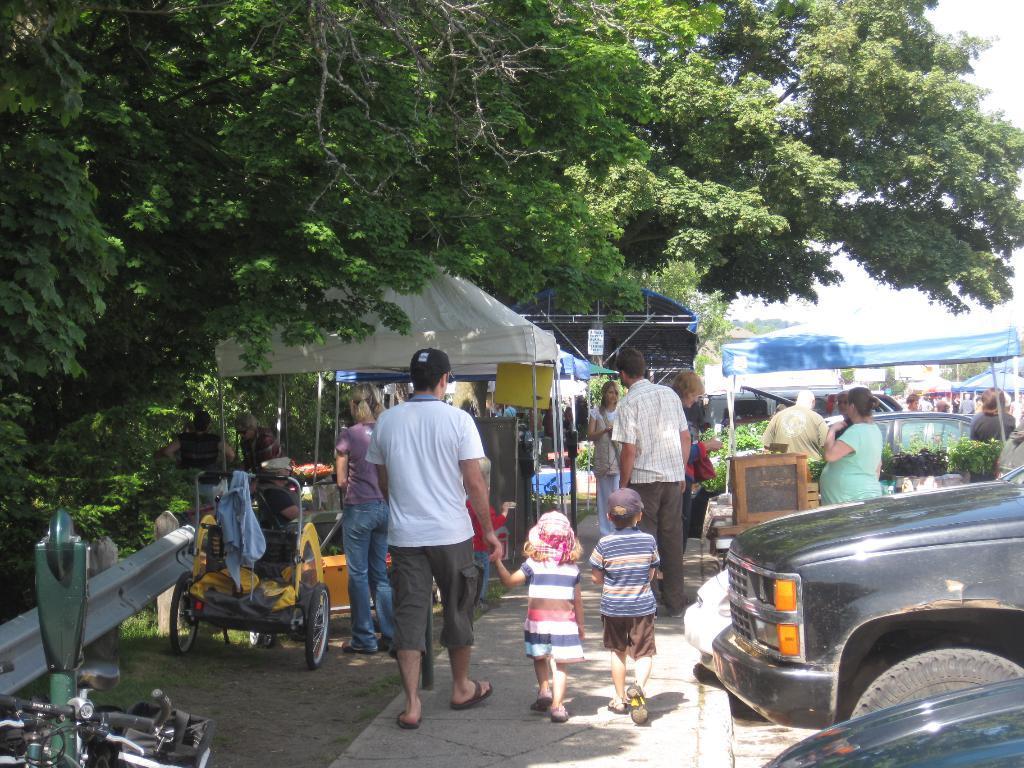Could you give a brief overview of what you see in this image? In this picture I can see few tents and trees and few people are walking and a woman standing and few vehicles parked and a cloudy sky and I can see few people wore caps on their heads. 